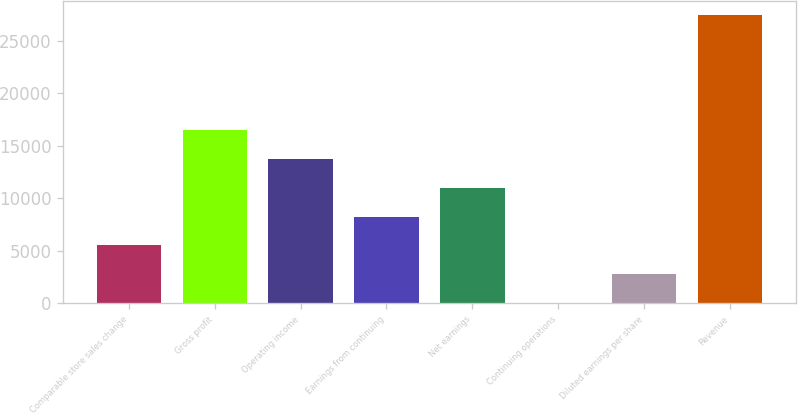Convert chart. <chart><loc_0><loc_0><loc_500><loc_500><bar_chart><fcel>Comparable store sales change<fcel>Gross profit<fcel>Operating income<fcel>Earnings from continuing<fcel>Net earnings<fcel>Continuing operations<fcel>Diluted earnings per share<fcel>Revenue<nl><fcel>5488.41<fcel>16460.7<fcel>13717.6<fcel>8231.48<fcel>10974.5<fcel>2.27<fcel>2745.34<fcel>27433<nl></chart> 